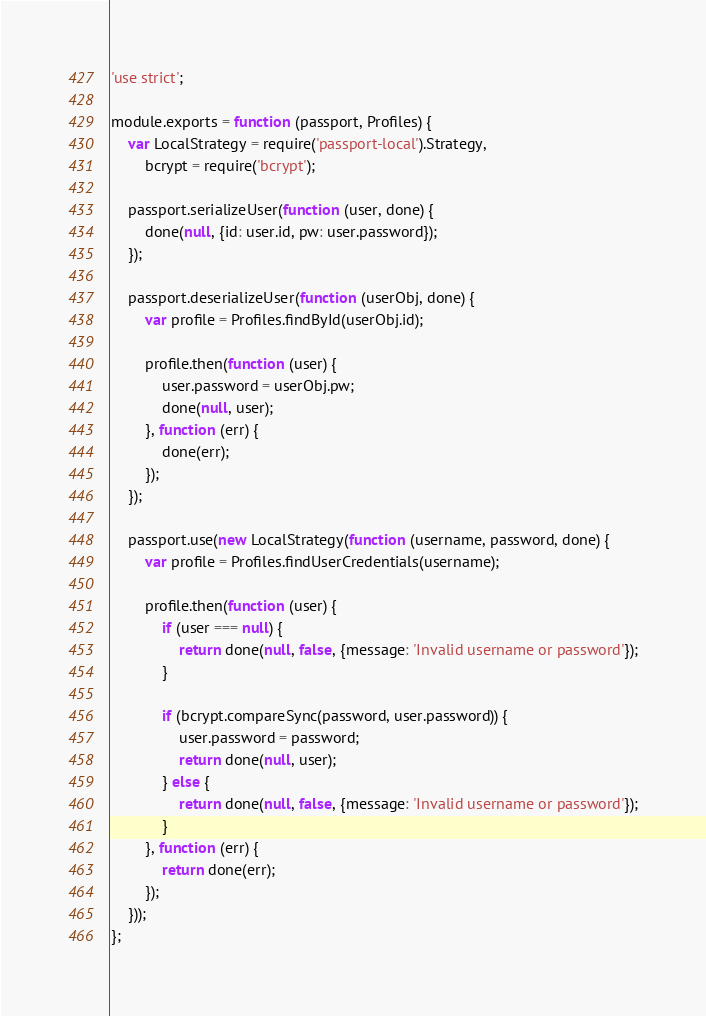<code> <loc_0><loc_0><loc_500><loc_500><_JavaScript_>'use strict';

module.exports = function (passport, Profiles) {
    var LocalStrategy = require('passport-local').Strategy,
        bcrypt = require('bcrypt');

    passport.serializeUser(function (user, done) {
        done(null, {id: user.id, pw: user.password});
    });

    passport.deserializeUser(function (userObj, done) {
        var profile = Profiles.findById(userObj.id);

        profile.then(function (user) {
            user.password = userObj.pw;
            done(null, user);
        }, function (err) {
            done(err);
        });
    });

    passport.use(new LocalStrategy(function (username, password, done) {
        var profile = Profiles.findUserCredentials(username);

        profile.then(function (user) {
            if (user === null) {
                return done(null, false, {message: 'Invalid username or password'});
            }

            if (bcrypt.compareSync(password, user.password)) {
                user.password = password;
                return done(null, user);
            } else {
                return done(null, false, {message: 'Invalid username or password'});
            }
        }, function (err) {
            return done(err);
        });
    }));
};</code> 